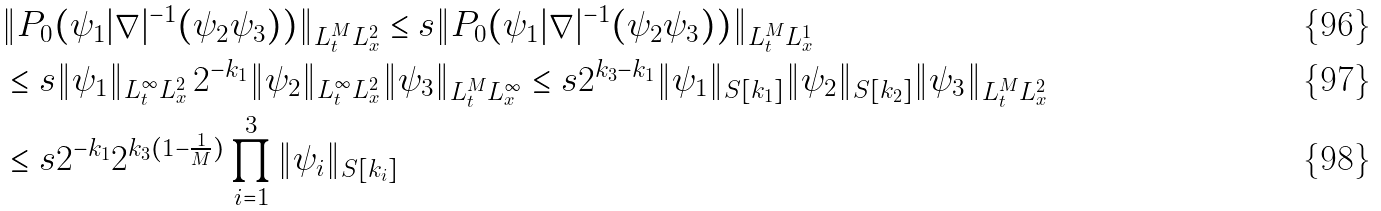<formula> <loc_0><loc_0><loc_500><loc_500>& \| P _ { 0 } ( \psi _ { 1 } | \nabla | ^ { - 1 } ( \psi _ { 2 } \psi _ { 3 } ) ) \| _ { L ^ { M } _ { t } L ^ { 2 } _ { x } } \leq s \| P _ { 0 } ( \psi _ { 1 } | \nabla | ^ { - 1 } ( \psi _ { 2 } \psi _ { 3 } ) ) \| _ { L ^ { M } _ { t } L ^ { 1 } _ { x } } \\ & \leq s \| \psi _ { 1 } \| _ { L ^ { \infty } _ { t } L ^ { 2 } _ { x } } \, 2 ^ { - k _ { 1 } } \| \psi _ { 2 } \| _ { L ^ { \infty } _ { t } L ^ { 2 } _ { x } } \| \psi _ { 3 } \| _ { L ^ { M } _ { t } L ^ { \infty } _ { x } } \leq s 2 ^ { k _ { 3 } - k _ { 1 } } \| \psi _ { 1 } \| _ { S [ k _ { 1 } ] } \| \psi _ { 2 } \| _ { S [ k _ { 2 } ] } \| \psi _ { 3 } \| _ { L ^ { M } _ { t } L ^ { 2 } _ { x } } \\ & \leq s 2 ^ { - k _ { 1 } } 2 ^ { k _ { 3 } ( 1 - \frac { 1 } { M } ) } \prod _ { i = 1 } ^ { 3 } \| \psi _ { i } \| _ { S [ k _ { i } ] }</formula> 